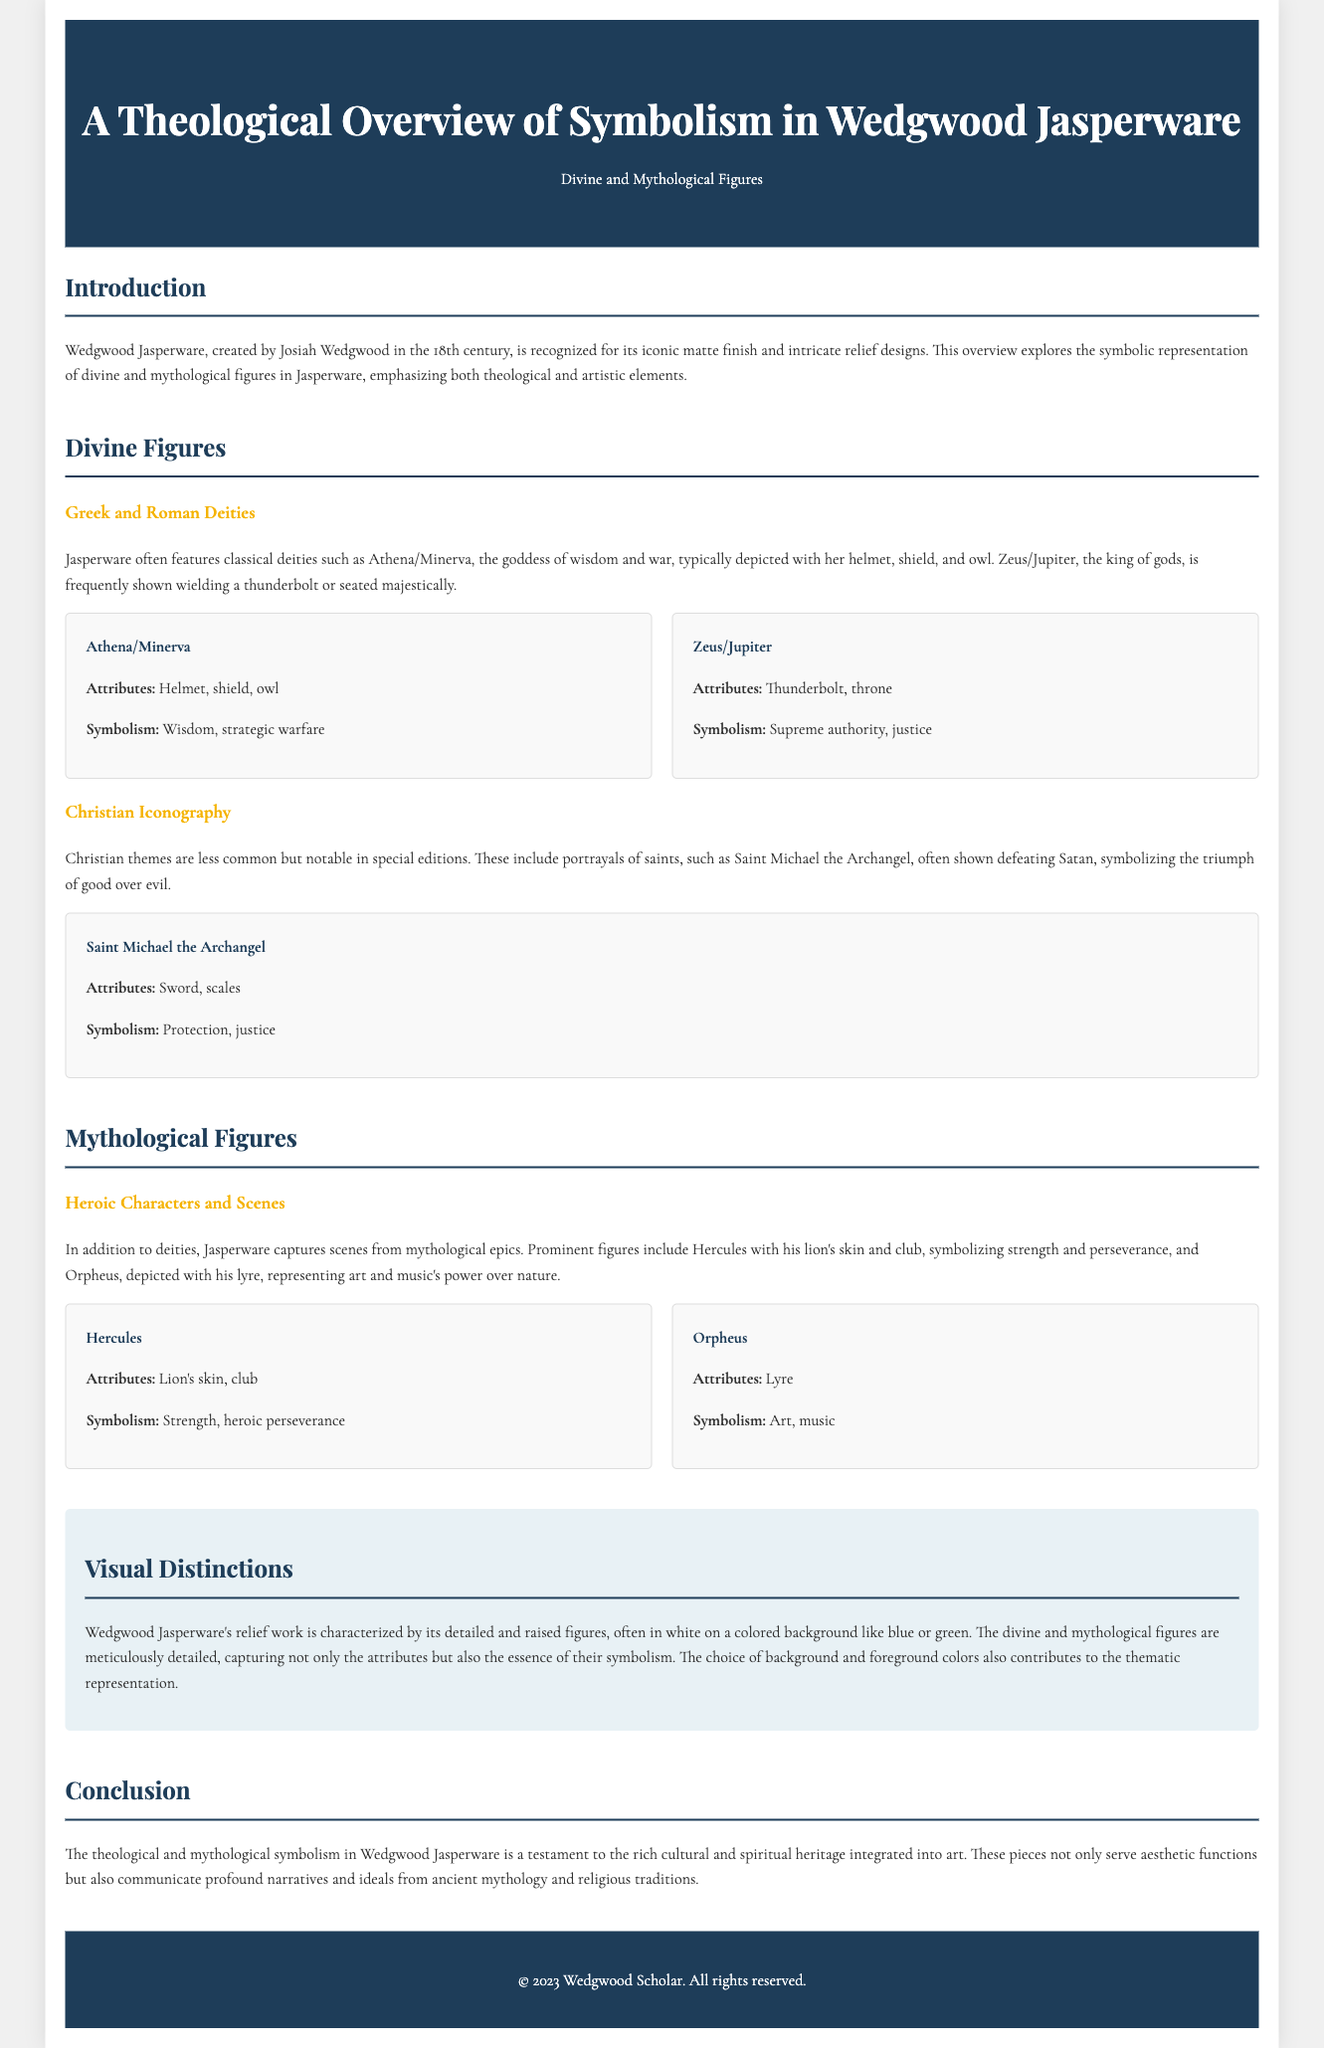what is Wedgwood Jasperware known for? The document states that Wedgwood Jasperware is recognized for its iconic matte finish and intricate relief designs.
Answer: iconic matte finish and intricate relief designs who is depicted with a sword and scales? The document mentions that Saint Michael the Archangel is often shown with a sword and scales.
Answer: Saint Michael the Archangel what symbolism is associated with Hercules? The document describes Hercules as symbolizing strength and heroic perseverance.
Answer: Strength, heroic perseverance how is Zeus/Jupiter commonly represented? Zeus/Jupiter is frequently shown wielding a thunderbolt or seated majestically, according to the document.
Answer: wielding a thunderbolt or seated majestically what background colors are commonly used in Wedgwood Jasperware? The document states that the relief work often features a colored background like blue or green.
Answer: blue or green which figure is represented with a lyre? The document indicates that Orpheus is depicted with a lyre.
Answer: Orpheus what is the primary focus of the document? The document explores the symbolic representation of divine and mythological figures in Jasperware, emphasizing theological and artistic elements.
Answer: symbolic representation of divine and mythological figures what type of iconography is less common in Jasperware? According to the document, Christian themes are less common in Jasperware.
Answer: Christian themes 